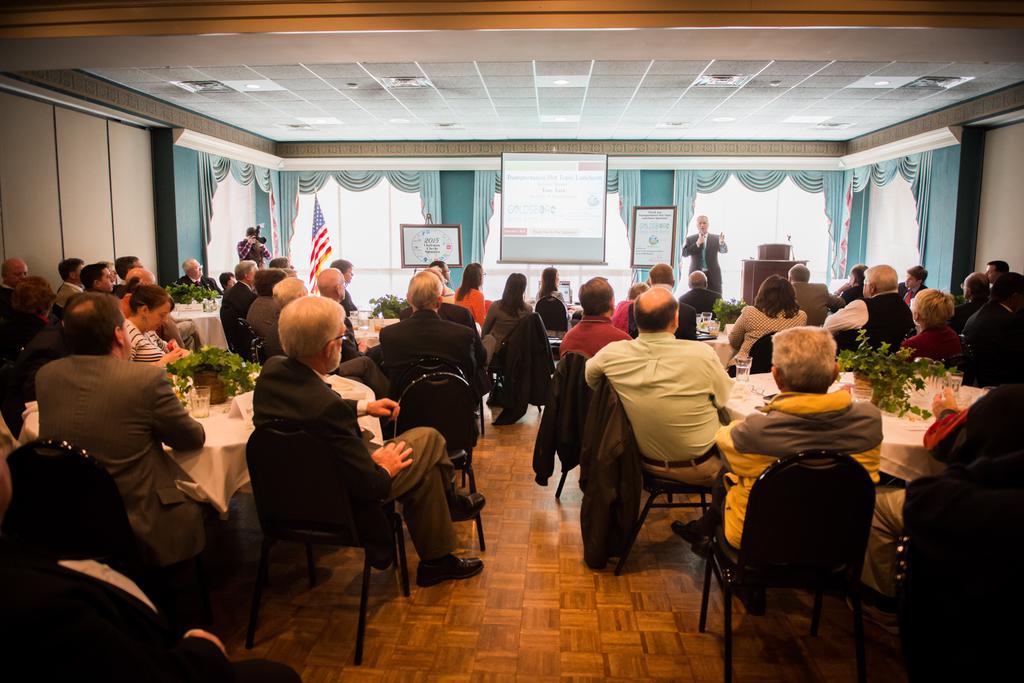In one or two sentences, can you explain what this image depicts? In this image I can see people were few are standing and rest all are sitting on chairs. I can see one of them is holding a camera. In the background I can see of flag, few boards and a screen. I can also see few tables and few plants on it. 